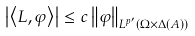<formula> <loc_0><loc_0><loc_500><loc_500>\left | \left \langle L , \varphi \right \rangle \right | \leq c \left \| \varphi \right \| _ { L ^ { p ^ { \prime } } \left ( \Omega \times \Delta \left ( A \right ) \right ) }</formula> 